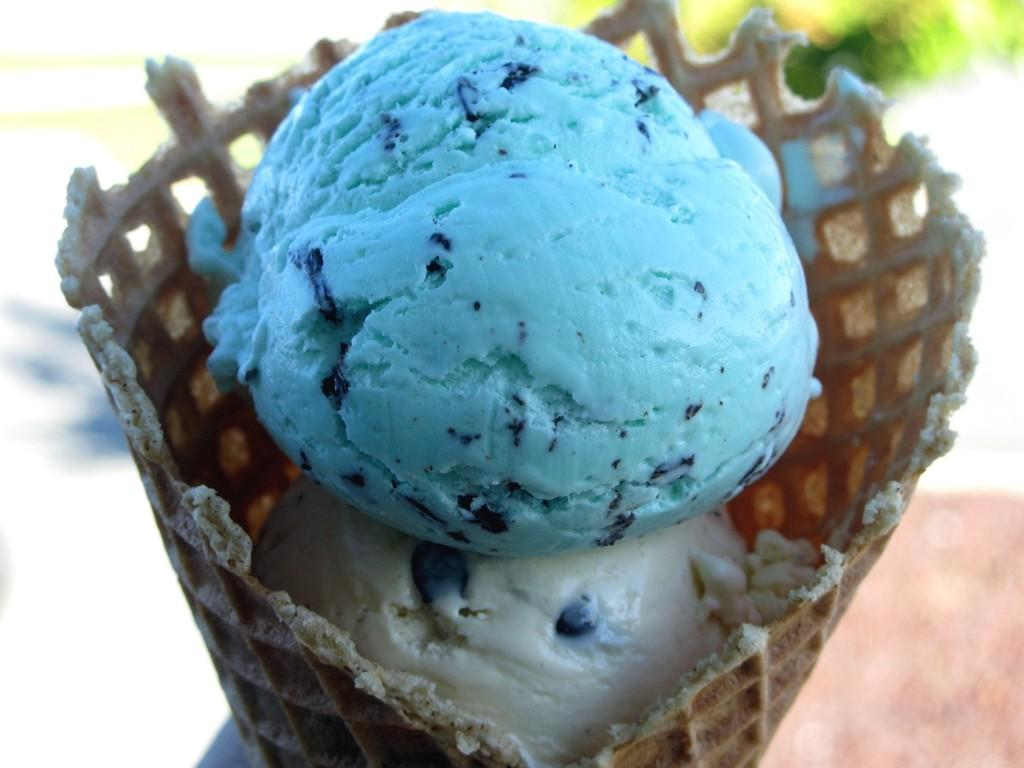How many scoops of ice cream are in the cone in the image? There are two scoops of ice cream in the cone in the image. What colors can be seen in the ice cream? The ice cream has white and blue colors. What type of wine is being served in the image? There is no wine present in the image; it features an ice cream cone with two scoops of ice cream. What material is the tank made of in the image? There is no tank present in the image. 